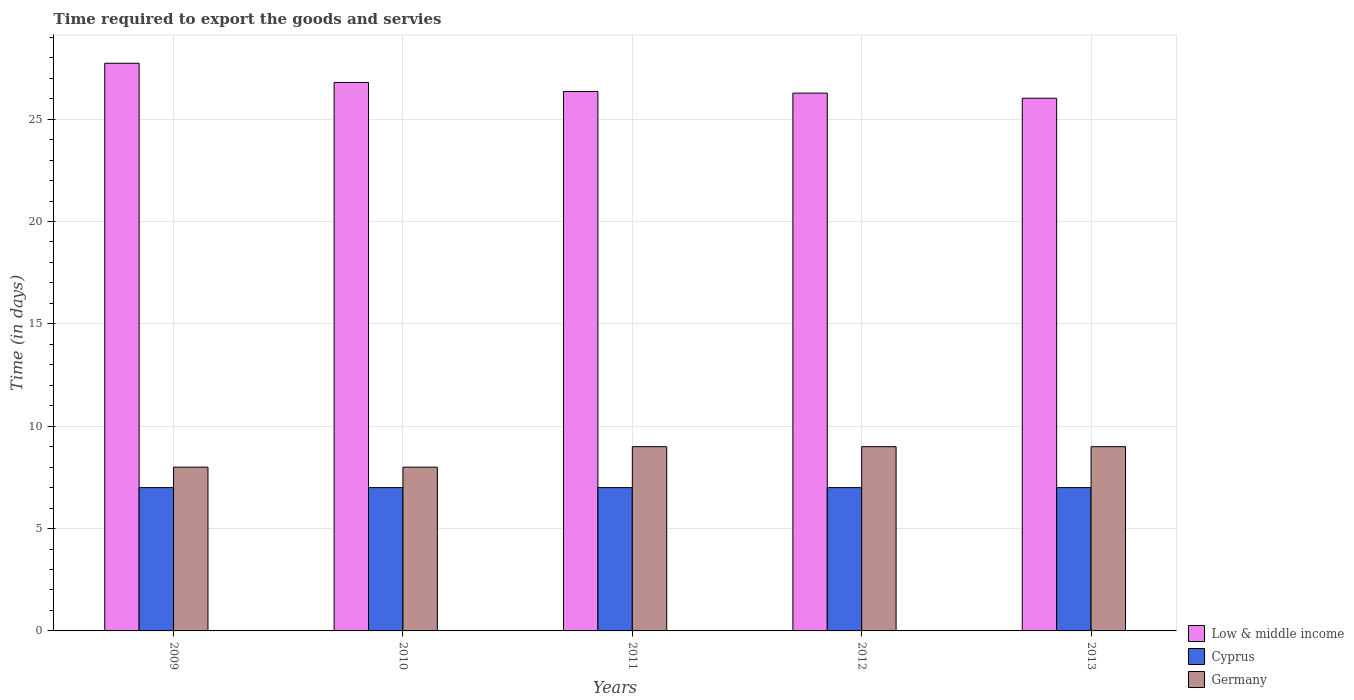How many groups of bars are there?
Offer a very short reply. 5. Are the number of bars per tick equal to the number of legend labels?
Your answer should be very brief. Yes. How many bars are there on the 5th tick from the left?
Make the answer very short. 3. What is the label of the 1st group of bars from the left?
Ensure brevity in your answer.  2009. What is the number of days required to export the goods and services in Cyprus in 2011?
Your answer should be compact. 7. Across all years, what is the maximum number of days required to export the goods and services in Germany?
Offer a terse response. 9. Across all years, what is the minimum number of days required to export the goods and services in Germany?
Make the answer very short. 8. In which year was the number of days required to export the goods and services in Germany minimum?
Keep it short and to the point. 2009. What is the total number of days required to export the goods and services in Germany in the graph?
Make the answer very short. 43. What is the difference between the number of days required to export the goods and services in Low & middle income in 2012 and that in 2013?
Keep it short and to the point. 0.25. What is the difference between the number of days required to export the goods and services in Low & middle income in 2012 and the number of days required to export the goods and services in Germany in 2013?
Your answer should be very brief. 17.27. What is the average number of days required to export the goods and services in Low & middle income per year?
Ensure brevity in your answer.  26.63. In the year 2010, what is the difference between the number of days required to export the goods and services in Cyprus and number of days required to export the goods and services in Low & middle income?
Provide a short and direct response. -19.79. In how many years, is the number of days required to export the goods and services in Cyprus greater than 3 days?
Ensure brevity in your answer.  5. What is the ratio of the number of days required to export the goods and services in Germany in 2010 to that in 2012?
Offer a terse response. 0.89. Is the number of days required to export the goods and services in Cyprus in 2010 less than that in 2013?
Offer a terse response. No. Is the difference between the number of days required to export the goods and services in Cyprus in 2009 and 2011 greater than the difference between the number of days required to export the goods and services in Low & middle income in 2009 and 2011?
Offer a terse response. No. What is the difference between the highest and the second highest number of days required to export the goods and services in Low & middle income?
Keep it short and to the point. 0.94. What is the difference between the highest and the lowest number of days required to export the goods and services in Germany?
Your response must be concise. 1. Is the sum of the number of days required to export the goods and services in Germany in 2010 and 2012 greater than the maximum number of days required to export the goods and services in Low & middle income across all years?
Provide a succinct answer. No. What does the 2nd bar from the left in 2011 represents?
Offer a very short reply. Cyprus. How many bars are there?
Ensure brevity in your answer.  15. How many years are there in the graph?
Make the answer very short. 5. What is the difference between two consecutive major ticks on the Y-axis?
Offer a terse response. 5. Does the graph contain grids?
Offer a very short reply. Yes. How many legend labels are there?
Your answer should be very brief. 3. What is the title of the graph?
Provide a succinct answer. Time required to export the goods and servies. What is the label or title of the X-axis?
Provide a succinct answer. Years. What is the label or title of the Y-axis?
Make the answer very short. Time (in days). What is the Time (in days) in Low & middle income in 2009?
Ensure brevity in your answer.  27.73. What is the Time (in days) of Low & middle income in 2010?
Your answer should be very brief. 26.79. What is the Time (in days) of Cyprus in 2010?
Ensure brevity in your answer.  7. What is the Time (in days) of Germany in 2010?
Ensure brevity in your answer.  8. What is the Time (in days) of Low & middle income in 2011?
Provide a short and direct response. 26.35. What is the Time (in days) in Cyprus in 2011?
Provide a short and direct response. 7. What is the Time (in days) of Low & middle income in 2012?
Offer a terse response. 26.27. What is the Time (in days) in Germany in 2012?
Keep it short and to the point. 9. What is the Time (in days) of Low & middle income in 2013?
Your response must be concise. 26.02. What is the Time (in days) of Germany in 2013?
Offer a very short reply. 9. Across all years, what is the maximum Time (in days) in Low & middle income?
Ensure brevity in your answer.  27.73. Across all years, what is the minimum Time (in days) of Low & middle income?
Keep it short and to the point. 26.02. Across all years, what is the minimum Time (in days) of Cyprus?
Offer a terse response. 7. Across all years, what is the minimum Time (in days) in Germany?
Give a very brief answer. 8. What is the total Time (in days) of Low & middle income in the graph?
Provide a succinct answer. 133.17. What is the total Time (in days) of Cyprus in the graph?
Your answer should be compact. 35. What is the difference between the Time (in days) of Low & middle income in 2009 and that in 2010?
Offer a very short reply. 0.94. What is the difference between the Time (in days) of Low & middle income in 2009 and that in 2011?
Offer a terse response. 1.38. What is the difference between the Time (in days) in Cyprus in 2009 and that in 2011?
Make the answer very short. 0. What is the difference between the Time (in days) in Low & middle income in 2009 and that in 2012?
Make the answer very short. 1.46. What is the difference between the Time (in days) of Cyprus in 2009 and that in 2012?
Offer a terse response. 0. What is the difference between the Time (in days) in Low & middle income in 2009 and that in 2013?
Offer a very short reply. 1.71. What is the difference between the Time (in days) in Germany in 2009 and that in 2013?
Your answer should be compact. -1. What is the difference between the Time (in days) in Low & middle income in 2010 and that in 2011?
Provide a succinct answer. 0.44. What is the difference between the Time (in days) of Germany in 2010 and that in 2011?
Ensure brevity in your answer.  -1. What is the difference between the Time (in days) in Low & middle income in 2010 and that in 2012?
Your answer should be very brief. 0.52. What is the difference between the Time (in days) in Low & middle income in 2010 and that in 2013?
Offer a very short reply. 0.77. What is the difference between the Time (in days) in Cyprus in 2010 and that in 2013?
Offer a very short reply. 0. What is the difference between the Time (in days) in Low & middle income in 2011 and that in 2012?
Provide a succinct answer. 0.08. What is the difference between the Time (in days) of Cyprus in 2011 and that in 2012?
Give a very brief answer. 0. What is the difference between the Time (in days) in Low & middle income in 2011 and that in 2013?
Provide a short and direct response. 0.33. What is the difference between the Time (in days) in Cyprus in 2011 and that in 2013?
Offer a very short reply. 0. What is the difference between the Time (in days) of Germany in 2011 and that in 2013?
Make the answer very short. 0. What is the difference between the Time (in days) of Low & middle income in 2012 and that in 2013?
Your answer should be compact. 0.25. What is the difference between the Time (in days) of Germany in 2012 and that in 2013?
Make the answer very short. 0. What is the difference between the Time (in days) of Low & middle income in 2009 and the Time (in days) of Cyprus in 2010?
Your answer should be compact. 20.73. What is the difference between the Time (in days) of Low & middle income in 2009 and the Time (in days) of Germany in 2010?
Your response must be concise. 19.73. What is the difference between the Time (in days) in Low & middle income in 2009 and the Time (in days) in Cyprus in 2011?
Provide a short and direct response. 20.73. What is the difference between the Time (in days) in Low & middle income in 2009 and the Time (in days) in Germany in 2011?
Provide a short and direct response. 18.73. What is the difference between the Time (in days) of Cyprus in 2009 and the Time (in days) of Germany in 2011?
Your answer should be compact. -2. What is the difference between the Time (in days) in Low & middle income in 2009 and the Time (in days) in Cyprus in 2012?
Keep it short and to the point. 20.73. What is the difference between the Time (in days) of Low & middle income in 2009 and the Time (in days) of Germany in 2012?
Provide a short and direct response. 18.73. What is the difference between the Time (in days) of Low & middle income in 2009 and the Time (in days) of Cyprus in 2013?
Ensure brevity in your answer.  20.73. What is the difference between the Time (in days) in Low & middle income in 2009 and the Time (in days) in Germany in 2013?
Your answer should be compact. 18.73. What is the difference between the Time (in days) of Cyprus in 2009 and the Time (in days) of Germany in 2013?
Keep it short and to the point. -2. What is the difference between the Time (in days) of Low & middle income in 2010 and the Time (in days) of Cyprus in 2011?
Your response must be concise. 19.79. What is the difference between the Time (in days) in Low & middle income in 2010 and the Time (in days) in Germany in 2011?
Your response must be concise. 17.79. What is the difference between the Time (in days) in Cyprus in 2010 and the Time (in days) in Germany in 2011?
Offer a terse response. -2. What is the difference between the Time (in days) of Low & middle income in 2010 and the Time (in days) of Cyprus in 2012?
Provide a short and direct response. 19.79. What is the difference between the Time (in days) of Low & middle income in 2010 and the Time (in days) of Germany in 2012?
Make the answer very short. 17.79. What is the difference between the Time (in days) of Cyprus in 2010 and the Time (in days) of Germany in 2012?
Offer a very short reply. -2. What is the difference between the Time (in days) in Low & middle income in 2010 and the Time (in days) in Cyprus in 2013?
Provide a short and direct response. 19.79. What is the difference between the Time (in days) in Low & middle income in 2010 and the Time (in days) in Germany in 2013?
Make the answer very short. 17.79. What is the difference between the Time (in days) in Cyprus in 2010 and the Time (in days) in Germany in 2013?
Make the answer very short. -2. What is the difference between the Time (in days) in Low & middle income in 2011 and the Time (in days) in Cyprus in 2012?
Provide a short and direct response. 19.35. What is the difference between the Time (in days) in Low & middle income in 2011 and the Time (in days) in Germany in 2012?
Your answer should be very brief. 17.35. What is the difference between the Time (in days) of Cyprus in 2011 and the Time (in days) of Germany in 2012?
Provide a short and direct response. -2. What is the difference between the Time (in days) of Low & middle income in 2011 and the Time (in days) of Cyprus in 2013?
Your answer should be very brief. 19.35. What is the difference between the Time (in days) of Low & middle income in 2011 and the Time (in days) of Germany in 2013?
Provide a short and direct response. 17.35. What is the difference between the Time (in days) in Low & middle income in 2012 and the Time (in days) in Cyprus in 2013?
Give a very brief answer. 19.27. What is the difference between the Time (in days) in Low & middle income in 2012 and the Time (in days) in Germany in 2013?
Your answer should be compact. 17.27. What is the average Time (in days) in Low & middle income per year?
Give a very brief answer. 26.63. What is the average Time (in days) in Germany per year?
Give a very brief answer. 8.6. In the year 2009, what is the difference between the Time (in days) of Low & middle income and Time (in days) of Cyprus?
Offer a very short reply. 20.73. In the year 2009, what is the difference between the Time (in days) in Low & middle income and Time (in days) in Germany?
Offer a very short reply. 19.73. In the year 2010, what is the difference between the Time (in days) in Low & middle income and Time (in days) in Cyprus?
Provide a succinct answer. 19.79. In the year 2010, what is the difference between the Time (in days) of Low & middle income and Time (in days) of Germany?
Provide a succinct answer. 18.79. In the year 2011, what is the difference between the Time (in days) of Low & middle income and Time (in days) of Cyprus?
Offer a terse response. 19.35. In the year 2011, what is the difference between the Time (in days) in Low & middle income and Time (in days) in Germany?
Your answer should be very brief. 17.35. In the year 2011, what is the difference between the Time (in days) of Cyprus and Time (in days) of Germany?
Give a very brief answer. -2. In the year 2012, what is the difference between the Time (in days) of Low & middle income and Time (in days) of Cyprus?
Your response must be concise. 19.27. In the year 2012, what is the difference between the Time (in days) of Low & middle income and Time (in days) of Germany?
Ensure brevity in your answer.  17.27. In the year 2013, what is the difference between the Time (in days) in Low & middle income and Time (in days) in Cyprus?
Your answer should be very brief. 19.02. In the year 2013, what is the difference between the Time (in days) in Low & middle income and Time (in days) in Germany?
Make the answer very short. 17.02. What is the ratio of the Time (in days) in Low & middle income in 2009 to that in 2010?
Keep it short and to the point. 1.03. What is the ratio of the Time (in days) of Cyprus in 2009 to that in 2010?
Offer a terse response. 1. What is the ratio of the Time (in days) in Low & middle income in 2009 to that in 2011?
Make the answer very short. 1.05. What is the ratio of the Time (in days) in Low & middle income in 2009 to that in 2012?
Offer a very short reply. 1.06. What is the ratio of the Time (in days) in Cyprus in 2009 to that in 2012?
Make the answer very short. 1. What is the ratio of the Time (in days) of Germany in 2009 to that in 2012?
Ensure brevity in your answer.  0.89. What is the ratio of the Time (in days) in Low & middle income in 2009 to that in 2013?
Provide a succinct answer. 1.07. What is the ratio of the Time (in days) of Cyprus in 2009 to that in 2013?
Offer a very short reply. 1. What is the ratio of the Time (in days) of Low & middle income in 2010 to that in 2011?
Offer a terse response. 1.02. What is the ratio of the Time (in days) of Cyprus in 2010 to that in 2011?
Provide a short and direct response. 1. What is the ratio of the Time (in days) of Low & middle income in 2010 to that in 2012?
Give a very brief answer. 1.02. What is the ratio of the Time (in days) in Low & middle income in 2010 to that in 2013?
Ensure brevity in your answer.  1.03. What is the ratio of the Time (in days) in Germany in 2011 to that in 2012?
Your answer should be compact. 1. What is the ratio of the Time (in days) of Low & middle income in 2011 to that in 2013?
Make the answer very short. 1.01. What is the ratio of the Time (in days) in Low & middle income in 2012 to that in 2013?
Ensure brevity in your answer.  1.01. What is the ratio of the Time (in days) in Germany in 2012 to that in 2013?
Your response must be concise. 1. What is the difference between the highest and the second highest Time (in days) of Low & middle income?
Offer a terse response. 0.94. What is the difference between the highest and the second highest Time (in days) of Germany?
Keep it short and to the point. 0. What is the difference between the highest and the lowest Time (in days) of Low & middle income?
Ensure brevity in your answer.  1.71. 